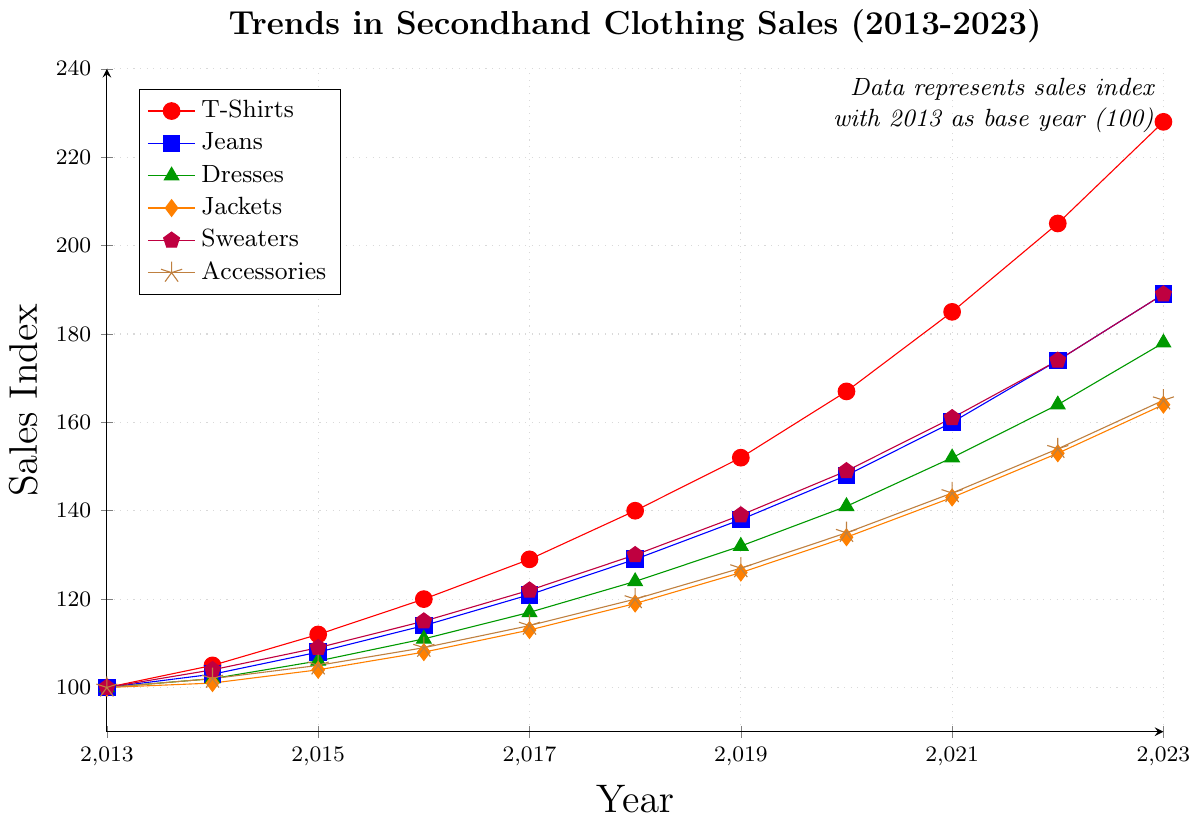What was the trend in T-Shirts sales from 2013 to 2023? The T-Shirts sales index started at 100 in 2013 and gradually increased each year, reaching 228 in 2023. This demonstrates a steady upward trend over the decade.
Answer: Steady upward trend Which clothing category had the highest sales index in 2021? By examining the plotted lines and their end values in 2021, the T-Shirts category had the highest sales index, marked at 185.
Answer: T-Shirts Between Jeans and Dresses, which category experienced a greater increase in sales index from 2015 to 2020? In 2015, Jeans had a sales index of 108, and by 2020, it reached 148, showing an increase of 40 points. Dresses started at 106 in 2015 and increased to 141 by 2020, showing an increase of 35 points. Therefore, Jeans experienced a greater increase.
Answer: Jeans Which category showed the least overall change in sales index from 2013 to 2023? By comparing the starting and ending points of all categories, Jackets showed the least change, starting at 100 in 2013 and ending at 164 in 2023, which is an increase of 64 points.
Answer: Jackets In which year did Sweaters surpass a sales index of 150? Referring to the Sweaters line, the sales index surpassed 150 in the year 2021, as it reached 161 that year.
Answer: 2021 Compare the growth trends of Accessories and Sweaters from 2017 to 2022. Which one had a more significant increase? Accessories had a sales index of 114 in 2017 and it increased to 154 by 2022. Sweaters had a sales index of 122 in 2017 and it increased to 174 by 2022. Accessories increased by 40 points whereas Sweaters increased by 52 points, showing that Sweaters had a more significant increase.
Answer: Sweaters Between 2019 and 2023, which category had the fastest growth rate? By calculating the difference in sales index for each category between 2019 and 2023: T-Shirts (228-152=76), Jeans (189-138=51), Dresses (178-132=46), Jackets (164-126=38), Sweaters (189-139=50), and Accessories (165-127=38). T-Shirts had the highest increase of 76 points.
Answer: T-Shirts Which categories had their sales index double from 2013 to 2023? To find categories that doubled, compare the 2023 sales index with double the 2013 index (100): T-Shirts (228 > 200), Jeans (189 < 200), Dresses (178 < 200), Jackets (164 < 200), Sweaters (189 < 200), Accessories (165 < 200). Only T-Shirts more than doubled.
Answer: T-Shirts What is the average sales index for T-Shirts across the given years 2013-2023? Sum the sales index values for T-Shirts from 2013 to 2023 and divide by the number of years: (100+105+112+120+129+140+152+167+185+205+228) / 11 = 164.09.
Answer: 164.09 